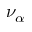Convert formula to latex. <formula><loc_0><loc_0><loc_500><loc_500>\nu _ { \alpha }</formula> 